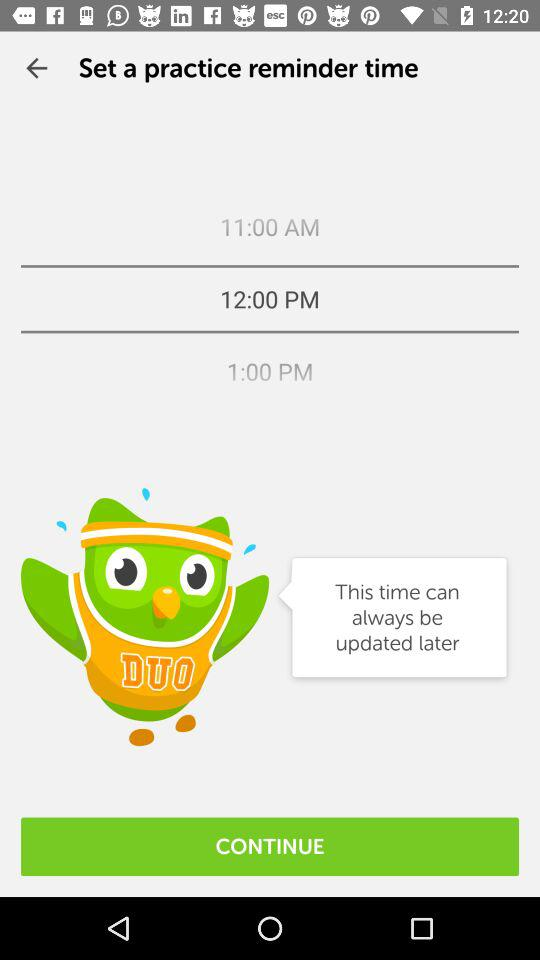What is the selected time? The selected time is 12:00 PM. 